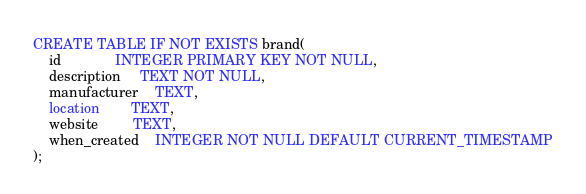Convert code to text. <code><loc_0><loc_0><loc_500><loc_500><_SQL_>CREATE TABLE IF NOT EXISTS brand(
    id              INTEGER PRIMARY KEY NOT NULL,
    description     TEXT NOT NULL,
    manufacturer    TEXT,
    location        TEXT,
    website         TEXT,
    when_created    INTEGER NOT NULL DEFAULT CURRENT_TIMESTAMP
);</code> 